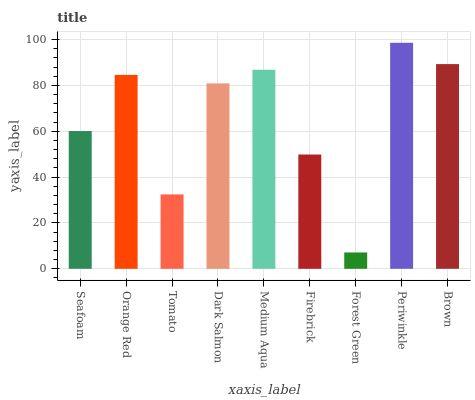Is Forest Green the minimum?
Answer yes or no. Yes. Is Periwinkle the maximum?
Answer yes or no. Yes. Is Orange Red the minimum?
Answer yes or no. No. Is Orange Red the maximum?
Answer yes or no. No. Is Orange Red greater than Seafoam?
Answer yes or no. Yes. Is Seafoam less than Orange Red?
Answer yes or no. Yes. Is Seafoam greater than Orange Red?
Answer yes or no. No. Is Orange Red less than Seafoam?
Answer yes or no. No. Is Dark Salmon the high median?
Answer yes or no. Yes. Is Dark Salmon the low median?
Answer yes or no. Yes. Is Periwinkle the high median?
Answer yes or no. No. Is Forest Green the low median?
Answer yes or no. No. 